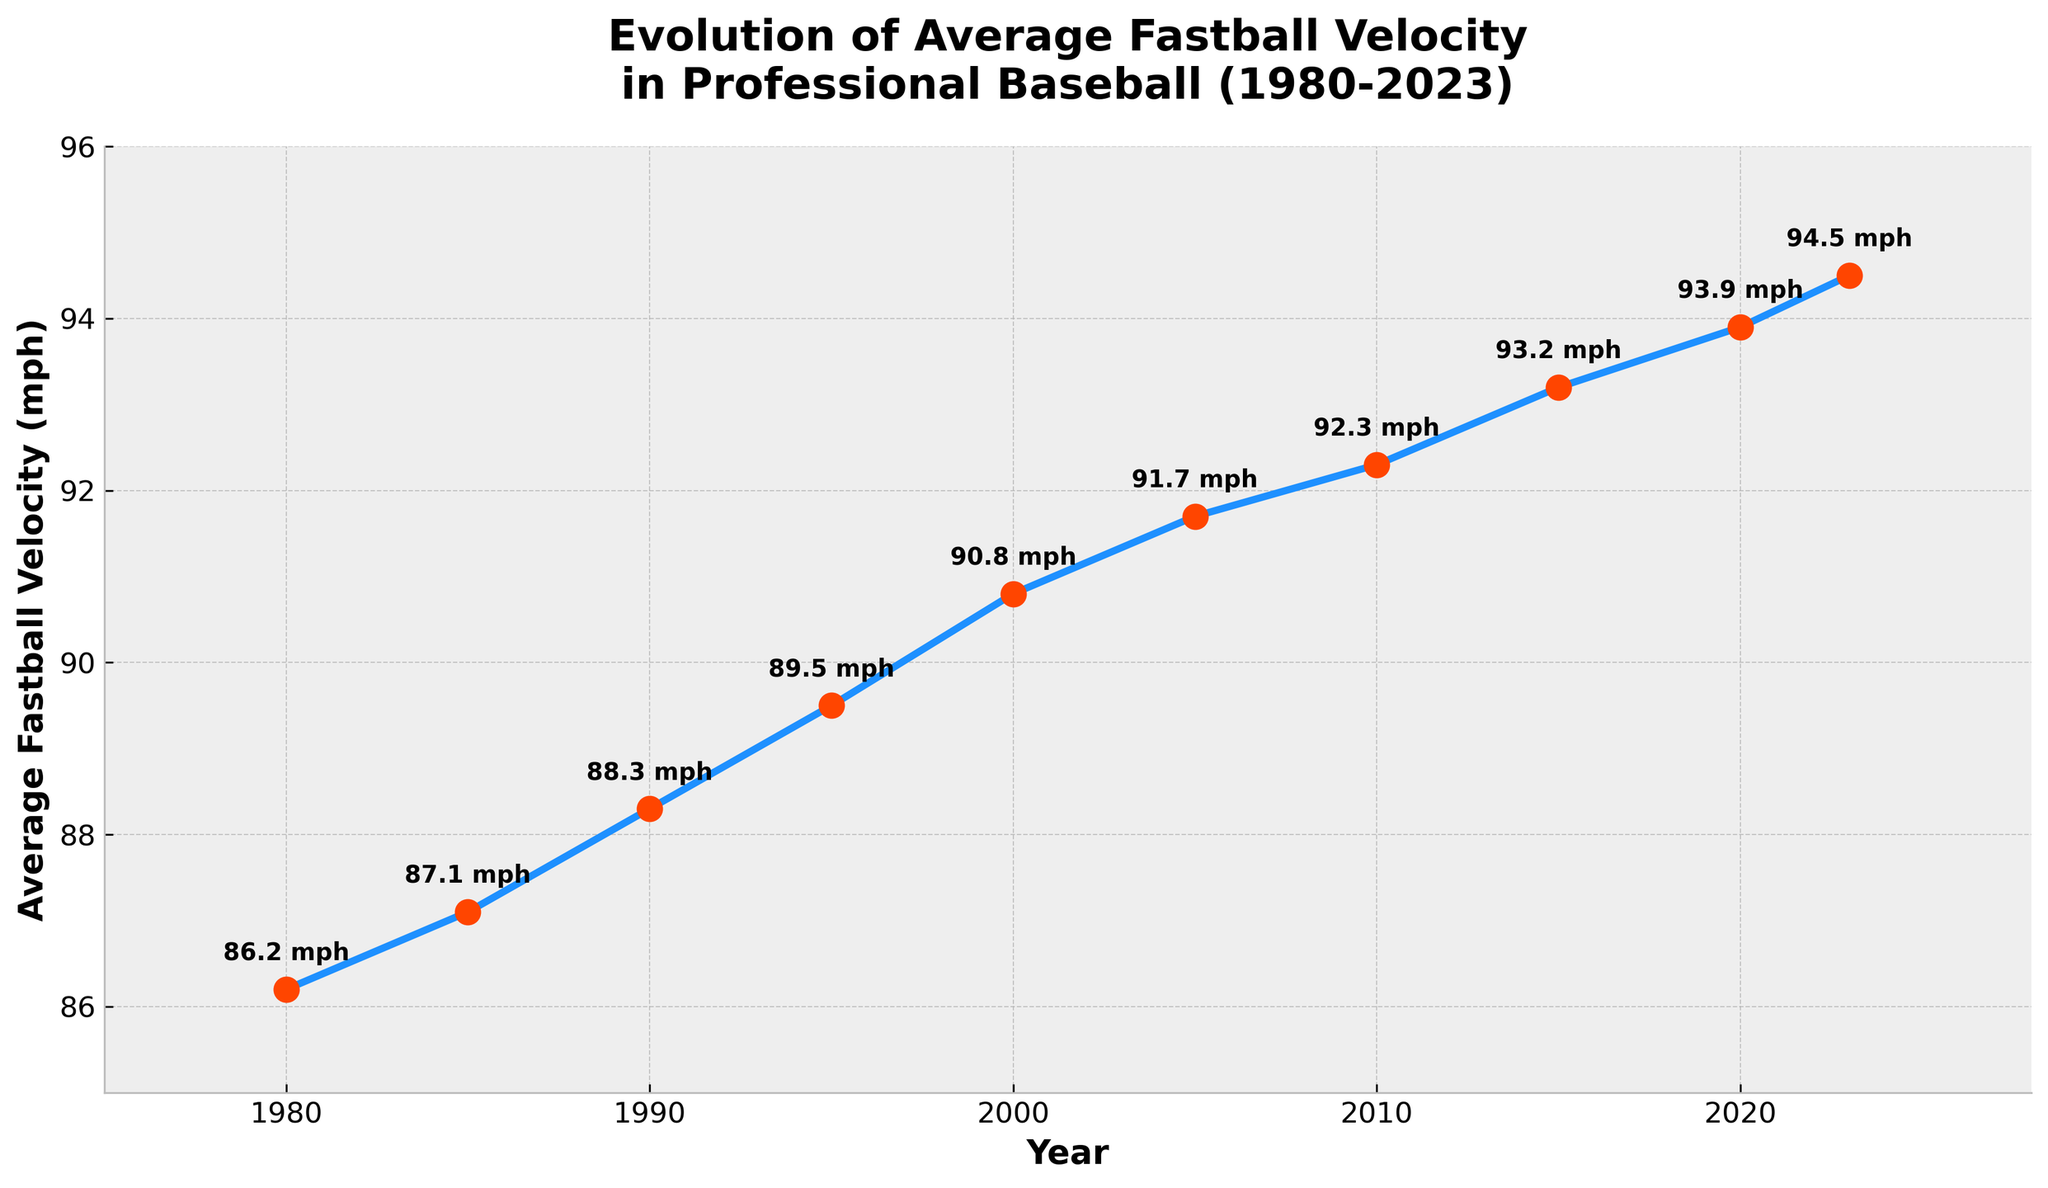What is the average fastball velocity recorded in the year 2023? Look at the plotted point corresponding to the year 2023 on the x-axis. Follow upward to its y-axis value, which is 94.5 mph.
Answer: 94.5 mph How much did the average fastball velocity increase from 1980 to 2023? Identify the velocities for 1980 and 2023, which are 86.2 mph and 94.5 mph, respectively. Subtract the 1980 value from the 2023 value: 94.5 - 86.2 = 8.3 mph.
Answer: 8.3 mph In which year did the average fastball velocity first exceed 90 mph? Look at the plotted points and their corresponding labels. The point where the velocity first exceeds 90 mph is in the year 2000, where it is 90.8 mph.
Answer: 2000 Between which consecutive years is the largest increase in average fastball velocity observed? Compare the differences in average fastball velocities between each consecutive set of years listed. The biggest jump is from 1995 (89.5 mph) to 2000 (90.8 mph), which is an increase of 1.3 mph.
Answer: Between 1995 and 2000 Which color is used to mark the year 2023 on the plot? Locate the year 2023 on the plot, and observe the color of the marker beside it, which is red.
Answer: Red What is the general trend observed in the average fastball velocity from 1980 to 2023? Observe the overall line connecting the plotted points. The general trend shows an increase in fastball velocity over time.
Answer: Increasing How does the average fastball velocity in 1990 compare to that in 2015? Locate the values of average fastball velocity for 1990 and 2015. In 1990, it is 88.3 mph, and in 2015, it is 93.2 mph. The velocity in 2015 is higher.
Answer: Velocity in 2015 is higher What is the range of average fastball velocities recorded between 1980 and 2023? Identify the highest and lowest average fastball velocities in the given years; the highest is 94.5 mph in 2023, and the lowest is 86.2 mph in 1980. The range is 94.5 - 86.2 = 8.3 mph.
Answer: 8.3 mph How many mph did the average fastball velocity increase between 2005 and 2015? Identify the velocities for 2005 and 2015, which are 91.7 mph and 93.2 mph, respectively. Subtract the 2005 value from the 2015 value: 93.2 - 91.7 = 1.5 mph.
Answer: 1.5 mph 